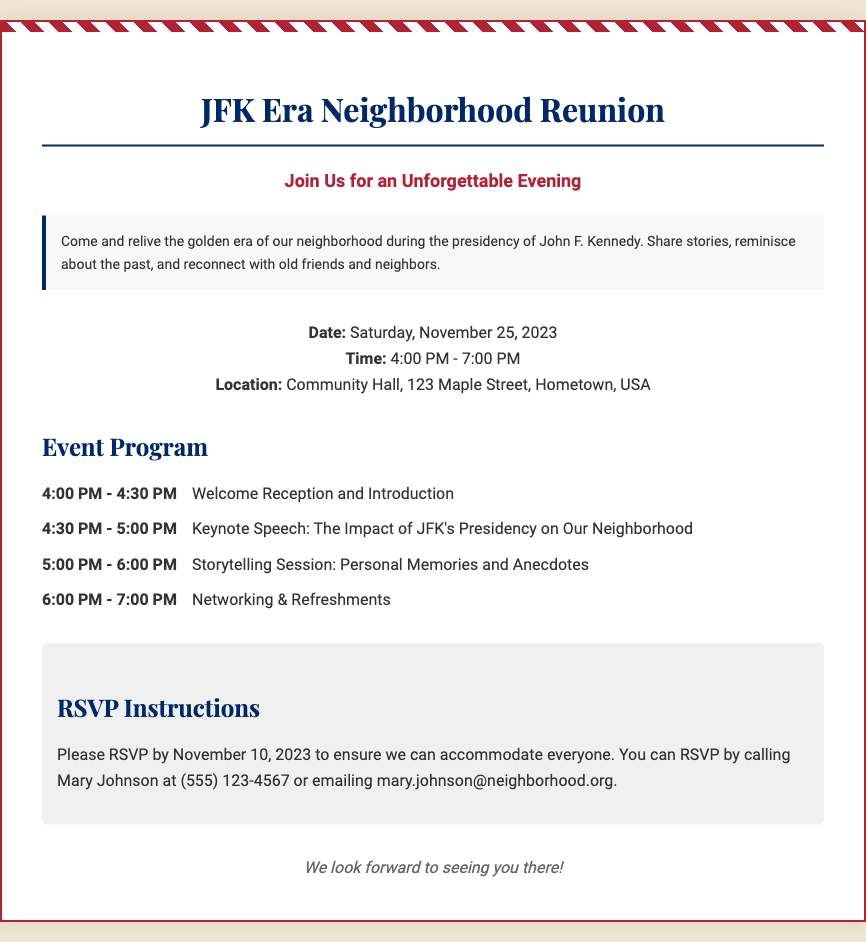What is the date of the reunion? The date of the reunion is mentioned directly in the event details section of the document.
Answer: Saturday, November 25, 2023 What time does the reunion start? The starting time is listed in the event details section of the document.
Answer: 4:00 PM What is the location of the reunion? The location is specified in the event details section of the document.
Answer: Community Hall, 123 Maple Street, Hometown, USA Who is giving the keynote speech? The document outlines a specific portion of the program indicating who will speak about JFK's impact.
Answer: Keynote Speech: The Impact of JFK's Presidency on Our Neighborhood How long is the storytelling session? The duration of the storytelling session is detailed in the event program section.
Answer: 1 hour What is the last date to RSVP? The RSVP deadline is clearly stated in the RSVP instructions section of the document.
Answer: November 10, 2023 How can attendees RSVP? The methods for RSVPing are outlined in the RSVP instructions section.
Answer: Calling or emailing What activity happens after the storytelling session? The program indicates which activity follows the storytelling session.
Answer: Networking & Refreshments What is the theme of the reunion? The introduction section specifies the overarching theme for the event.
Answer: JFK Era Neighborhood 